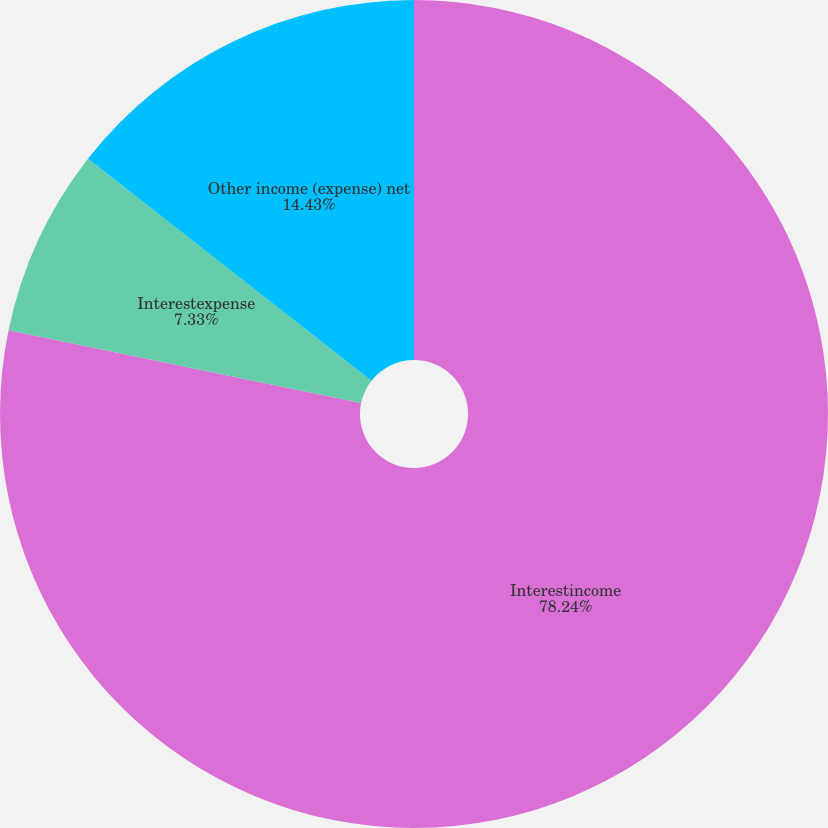<chart> <loc_0><loc_0><loc_500><loc_500><pie_chart><fcel>Interestincome<fcel>Interestexpense<fcel>Other income (expense) net<nl><fcel>78.24%<fcel>7.33%<fcel>14.43%<nl></chart> 